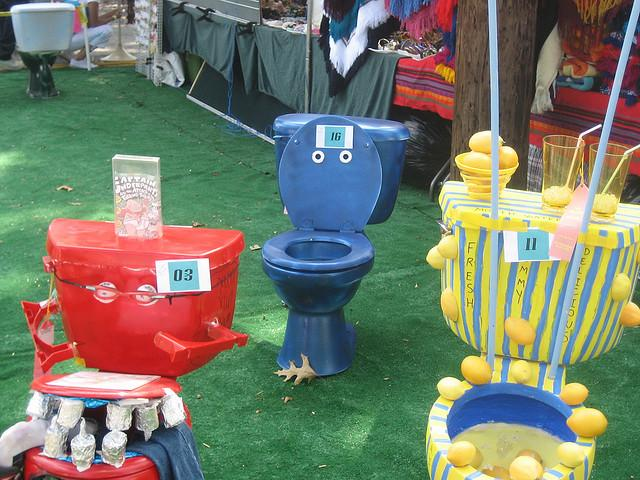The artistically displayed items here are normally connected to what?

Choices:
A) solar panels
B) roofs
C) electricity
D) plumbing plumbing 